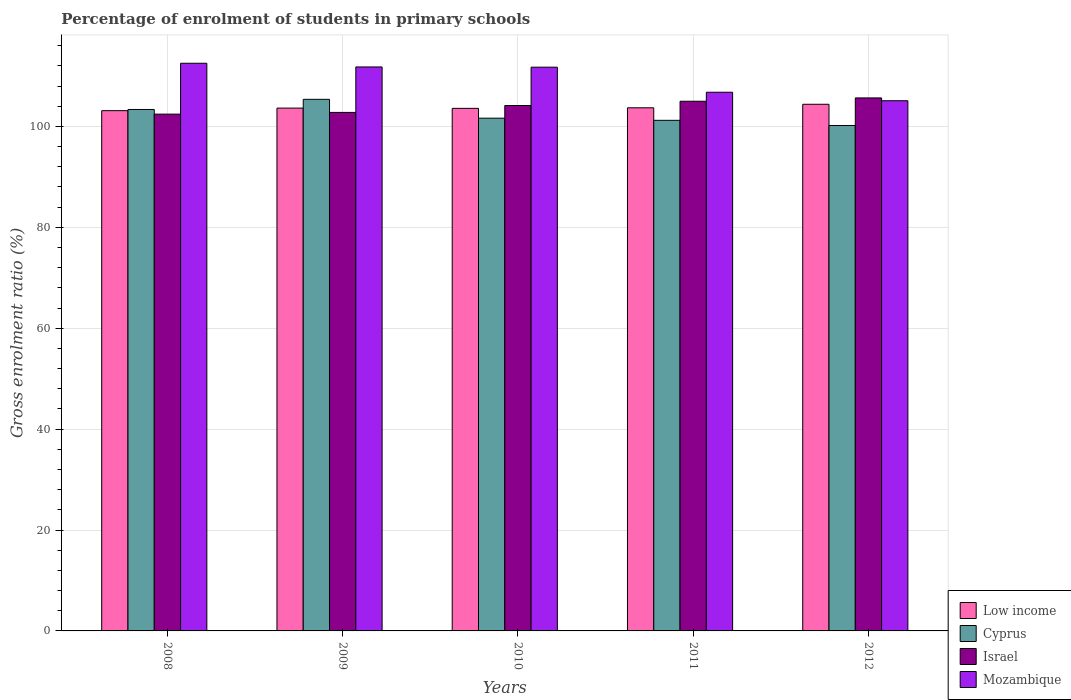How many groups of bars are there?
Your answer should be compact. 5. How many bars are there on the 2nd tick from the left?
Your answer should be very brief. 4. In how many cases, is the number of bars for a given year not equal to the number of legend labels?
Your response must be concise. 0. What is the percentage of students enrolled in primary schools in Israel in 2011?
Offer a terse response. 104.98. Across all years, what is the maximum percentage of students enrolled in primary schools in Cyprus?
Keep it short and to the point. 105.36. Across all years, what is the minimum percentage of students enrolled in primary schools in Mozambique?
Give a very brief answer. 105.08. In which year was the percentage of students enrolled in primary schools in Cyprus maximum?
Your response must be concise. 2009. In which year was the percentage of students enrolled in primary schools in Low income minimum?
Ensure brevity in your answer.  2008. What is the total percentage of students enrolled in primary schools in Israel in the graph?
Give a very brief answer. 519.96. What is the difference between the percentage of students enrolled in primary schools in Israel in 2010 and that in 2011?
Your answer should be compact. -0.85. What is the difference between the percentage of students enrolled in primary schools in Cyprus in 2008 and the percentage of students enrolled in primary schools in Low income in 2010?
Provide a short and direct response. -0.22. What is the average percentage of students enrolled in primary schools in Israel per year?
Your response must be concise. 103.99. In the year 2011, what is the difference between the percentage of students enrolled in primary schools in Low income and percentage of students enrolled in primary schools in Israel?
Make the answer very short. -1.3. In how many years, is the percentage of students enrolled in primary schools in Israel greater than 48 %?
Keep it short and to the point. 5. What is the ratio of the percentage of students enrolled in primary schools in Low income in 2009 to that in 2012?
Make the answer very short. 0.99. Is the difference between the percentage of students enrolled in primary schools in Low income in 2009 and 2010 greater than the difference between the percentage of students enrolled in primary schools in Israel in 2009 and 2010?
Your response must be concise. Yes. What is the difference between the highest and the second highest percentage of students enrolled in primary schools in Mozambique?
Your answer should be very brief. 0.73. What is the difference between the highest and the lowest percentage of students enrolled in primary schools in Cyprus?
Provide a succinct answer. 5.19. What does the 2nd bar from the left in 2012 represents?
Your response must be concise. Cyprus. What does the 1st bar from the right in 2009 represents?
Make the answer very short. Mozambique. Are all the bars in the graph horizontal?
Provide a short and direct response. No. Does the graph contain any zero values?
Offer a terse response. No. How are the legend labels stacked?
Make the answer very short. Vertical. What is the title of the graph?
Make the answer very short. Percentage of enrolment of students in primary schools. Does "United Arab Emirates" appear as one of the legend labels in the graph?
Ensure brevity in your answer.  No. What is the label or title of the Y-axis?
Your response must be concise. Gross enrolment ratio (%). What is the Gross enrolment ratio (%) in Low income in 2008?
Keep it short and to the point. 103.11. What is the Gross enrolment ratio (%) of Cyprus in 2008?
Give a very brief answer. 103.35. What is the Gross enrolment ratio (%) in Israel in 2008?
Your answer should be compact. 102.43. What is the Gross enrolment ratio (%) of Mozambique in 2008?
Give a very brief answer. 112.51. What is the Gross enrolment ratio (%) in Low income in 2009?
Your response must be concise. 103.62. What is the Gross enrolment ratio (%) in Cyprus in 2009?
Ensure brevity in your answer.  105.36. What is the Gross enrolment ratio (%) of Israel in 2009?
Your response must be concise. 102.77. What is the Gross enrolment ratio (%) of Mozambique in 2009?
Keep it short and to the point. 111.78. What is the Gross enrolment ratio (%) of Low income in 2010?
Give a very brief answer. 103.57. What is the Gross enrolment ratio (%) in Cyprus in 2010?
Your answer should be compact. 101.62. What is the Gross enrolment ratio (%) in Israel in 2010?
Offer a very short reply. 104.14. What is the Gross enrolment ratio (%) of Mozambique in 2010?
Keep it short and to the point. 111.73. What is the Gross enrolment ratio (%) in Low income in 2011?
Offer a terse response. 103.68. What is the Gross enrolment ratio (%) in Cyprus in 2011?
Your answer should be very brief. 101.2. What is the Gross enrolment ratio (%) of Israel in 2011?
Keep it short and to the point. 104.98. What is the Gross enrolment ratio (%) in Mozambique in 2011?
Your response must be concise. 106.77. What is the Gross enrolment ratio (%) of Low income in 2012?
Your answer should be compact. 104.38. What is the Gross enrolment ratio (%) of Cyprus in 2012?
Keep it short and to the point. 100.18. What is the Gross enrolment ratio (%) of Israel in 2012?
Your answer should be very brief. 105.64. What is the Gross enrolment ratio (%) of Mozambique in 2012?
Provide a short and direct response. 105.08. Across all years, what is the maximum Gross enrolment ratio (%) in Low income?
Make the answer very short. 104.38. Across all years, what is the maximum Gross enrolment ratio (%) of Cyprus?
Ensure brevity in your answer.  105.36. Across all years, what is the maximum Gross enrolment ratio (%) of Israel?
Offer a terse response. 105.64. Across all years, what is the maximum Gross enrolment ratio (%) of Mozambique?
Provide a succinct answer. 112.51. Across all years, what is the minimum Gross enrolment ratio (%) of Low income?
Your response must be concise. 103.11. Across all years, what is the minimum Gross enrolment ratio (%) in Cyprus?
Give a very brief answer. 100.18. Across all years, what is the minimum Gross enrolment ratio (%) in Israel?
Offer a very short reply. 102.43. Across all years, what is the minimum Gross enrolment ratio (%) in Mozambique?
Provide a short and direct response. 105.08. What is the total Gross enrolment ratio (%) in Low income in the graph?
Provide a succinct answer. 518.38. What is the total Gross enrolment ratio (%) in Cyprus in the graph?
Offer a terse response. 511.72. What is the total Gross enrolment ratio (%) of Israel in the graph?
Your answer should be compact. 519.96. What is the total Gross enrolment ratio (%) in Mozambique in the graph?
Keep it short and to the point. 547.87. What is the difference between the Gross enrolment ratio (%) of Low income in 2008 and that in 2009?
Provide a short and direct response. -0.51. What is the difference between the Gross enrolment ratio (%) of Cyprus in 2008 and that in 2009?
Offer a terse response. -2.01. What is the difference between the Gross enrolment ratio (%) in Israel in 2008 and that in 2009?
Your response must be concise. -0.34. What is the difference between the Gross enrolment ratio (%) in Mozambique in 2008 and that in 2009?
Provide a short and direct response. 0.73. What is the difference between the Gross enrolment ratio (%) of Low income in 2008 and that in 2010?
Your answer should be very brief. -0.46. What is the difference between the Gross enrolment ratio (%) in Cyprus in 2008 and that in 2010?
Keep it short and to the point. 1.73. What is the difference between the Gross enrolment ratio (%) of Israel in 2008 and that in 2010?
Ensure brevity in your answer.  -1.71. What is the difference between the Gross enrolment ratio (%) in Mozambique in 2008 and that in 2010?
Your answer should be very brief. 0.78. What is the difference between the Gross enrolment ratio (%) in Low income in 2008 and that in 2011?
Offer a terse response. -0.57. What is the difference between the Gross enrolment ratio (%) in Cyprus in 2008 and that in 2011?
Ensure brevity in your answer.  2.15. What is the difference between the Gross enrolment ratio (%) of Israel in 2008 and that in 2011?
Ensure brevity in your answer.  -2.56. What is the difference between the Gross enrolment ratio (%) in Mozambique in 2008 and that in 2011?
Offer a terse response. 5.74. What is the difference between the Gross enrolment ratio (%) in Low income in 2008 and that in 2012?
Keep it short and to the point. -1.27. What is the difference between the Gross enrolment ratio (%) in Cyprus in 2008 and that in 2012?
Your answer should be compact. 3.18. What is the difference between the Gross enrolment ratio (%) of Israel in 2008 and that in 2012?
Offer a very short reply. -3.21. What is the difference between the Gross enrolment ratio (%) of Mozambique in 2008 and that in 2012?
Offer a terse response. 7.43. What is the difference between the Gross enrolment ratio (%) of Low income in 2009 and that in 2010?
Your response must be concise. 0.05. What is the difference between the Gross enrolment ratio (%) in Cyprus in 2009 and that in 2010?
Your answer should be very brief. 3.74. What is the difference between the Gross enrolment ratio (%) of Israel in 2009 and that in 2010?
Your answer should be very brief. -1.37. What is the difference between the Gross enrolment ratio (%) in Mozambique in 2009 and that in 2010?
Provide a short and direct response. 0.05. What is the difference between the Gross enrolment ratio (%) of Low income in 2009 and that in 2011?
Make the answer very short. -0.06. What is the difference between the Gross enrolment ratio (%) of Cyprus in 2009 and that in 2011?
Offer a very short reply. 4.16. What is the difference between the Gross enrolment ratio (%) in Israel in 2009 and that in 2011?
Your response must be concise. -2.21. What is the difference between the Gross enrolment ratio (%) in Mozambique in 2009 and that in 2011?
Your answer should be compact. 5.01. What is the difference between the Gross enrolment ratio (%) in Low income in 2009 and that in 2012?
Your answer should be very brief. -0.76. What is the difference between the Gross enrolment ratio (%) of Cyprus in 2009 and that in 2012?
Keep it short and to the point. 5.19. What is the difference between the Gross enrolment ratio (%) of Israel in 2009 and that in 2012?
Ensure brevity in your answer.  -2.87. What is the difference between the Gross enrolment ratio (%) in Mozambique in 2009 and that in 2012?
Provide a succinct answer. 6.7. What is the difference between the Gross enrolment ratio (%) in Low income in 2010 and that in 2011?
Your response must be concise. -0.11. What is the difference between the Gross enrolment ratio (%) of Cyprus in 2010 and that in 2011?
Make the answer very short. 0.42. What is the difference between the Gross enrolment ratio (%) in Israel in 2010 and that in 2011?
Ensure brevity in your answer.  -0.85. What is the difference between the Gross enrolment ratio (%) of Mozambique in 2010 and that in 2011?
Your answer should be very brief. 4.96. What is the difference between the Gross enrolment ratio (%) of Low income in 2010 and that in 2012?
Provide a succinct answer. -0.81. What is the difference between the Gross enrolment ratio (%) in Cyprus in 2010 and that in 2012?
Your answer should be compact. 1.45. What is the difference between the Gross enrolment ratio (%) in Israel in 2010 and that in 2012?
Give a very brief answer. -1.5. What is the difference between the Gross enrolment ratio (%) in Mozambique in 2010 and that in 2012?
Provide a succinct answer. 6.65. What is the difference between the Gross enrolment ratio (%) in Low income in 2011 and that in 2012?
Keep it short and to the point. -0.7. What is the difference between the Gross enrolment ratio (%) in Cyprus in 2011 and that in 2012?
Make the answer very short. 1.03. What is the difference between the Gross enrolment ratio (%) of Israel in 2011 and that in 2012?
Ensure brevity in your answer.  -0.66. What is the difference between the Gross enrolment ratio (%) of Mozambique in 2011 and that in 2012?
Provide a short and direct response. 1.68. What is the difference between the Gross enrolment ratio (%) of Low income in 2008 and the Gross enrolment ratio (%) of Cyprus in 2009?
Your response must be concise. -2.25. What is the difference between the Gross enrolment ratio (%) of Low income in 2008 and the Gross enrolment ratio (%) of Israel in 2009?
Ensure brevity in your answer.  0.34. What is the difference between the Gross enrolment ratio (%) of Low income in 2008 and the Gross enrolment ratio (%) of Mozambique in 2009?
Offer a terse response. -8.66. What is the difference between the Gross enrolment ratio (%) of Cyprus in 2008 and the Gross enrolment ratio (%) of Israel in 2009?
Make the answer very short. 0.58. What is the difference between the Gross enrolment ratio (%) in Cyprus in 2008 and the Gross enrolment ratio (%) in Mozambique in 2009?
Make the answer very short. -8.43. What is the difference between the Gross enrolment ratio (%) of Israel in 2008 and the Gross enrolment ratio (%) of Mozambique in 2009?
Offer a very short reply. -9.35. What is the difference between the Gross enrolment ratio (%) in Low income in 2008 and the Gross enrolment ratio (%) in Cyprus in 2010?
Offer a terse response. 1.49. What is the difference between the Gross enrolment ratio (%) of Low income in 2008 and the Gross enrolment ratio (%) of Israel in 2010?
Provide a short and direct response. -1.02. What is the difference between the Gross enrolment ratio (%) in Low income in 2008 and the Gross enrolment ratio (%) in Mozambique in 2010?
Your answer should be very brief. -8.62. What is the difference between the Gross enrolment ratio (%) of Cyprus in 2008 and the Gross enrolment ratio (%) of Israel in 2010?
Offer a very short reply. -0.79. What is the difference between the Gross enrolment ratio (%) of Cyprus in 2008 and the Gross enrolment ratio (%) of Mozambique in 2010?
Provide a short and direct response. -8.38. What is the difference between the Gross enrolment ratio (%) in Israel in 2008 and the Gross enrolment ratio (%) in Mozambique in 2010?
Offer a very short reply. -9.3. What is the difference between the Gross enrolment ratio (%) in Low income in 2008 and the Gross enrolment ratio (%) in Cyprus in 2011?
Your answer should be compact. 1.91. What is the difference between the Gross enrolment ratio (%) of Low income in 2008 and the Gross enrolment ratio (%) of Israel in 2011?
Keep it short and to the point. -1.87. What is the difference between the Gross enrolment ratio (%) in Low income in 2008 and the Gross enrolment ratio (%) in Mozambique in 2011?
Give a very brief answer. -3.65. What is the difference between the Gross enrolment ratio (%) of Cyprus in 2008 and the Gross enrolment ratio (%) of Israel in 2011?
Offer a very short reply. -1.63. What is the difference between the Gross enrolment ratio (%) in Cyprus in 2008 and the Gross enrolment ratio (%) in Mozambique in 2011?
Your answer should be compact. -3.42. What is the difference between the Gross enrolment ratio (%) of Israel in 2008 and the Gross enrolment ratio (%) of Mozambique in 2011?
Offer a very short reply. -4.34. What is the difference between the Gross enrolment ratio (%) of Low income in 2008 and the Gross enrolment ratio (%) of Cyprus in 2012?
Give a very brief answer. 2.94. What is the difference between the Gross enrolment ratio (%) in Low income in 2008 and the Gross enrolment ratio (%) in Israel in 2012?
Your response must be concise. -2.53. What is the difference between the Gross enrolment ratio (%) of Low income in 2008 and the Gross enrolment ratio (%) of Mozambique in 2012?
Provide a short and direct response. -1.97. What is the difference between the Gross enrolment ratio (%) of Cyprus in 2008 and the Gross enrolment ratio (%) of Israel in 2012?
Offer a very short reply. -2.29. What is the difference between the Gross enrolment ratio (%) in Cyprus in 2008 and the Gross enrolment ratio (%) in Mozambique in 2012?
Keep it short and to the point. -1.73. What is the difference between the Gross enrolment ratio (%) of Israel in 2008 and the Gross enrolment ratio (%) of Mozambique in 2012?
Your answer should be very brief. -2.65. What is the difference between the Gross enrolment ratio (%) in Low income in 2009 and the Gross enrolment ratio (%) in Cyprus in 2010?
Provide a short and direct response. 2. What is the difference between the Gross enrolment ratio (%) of Low income in 2009 and the Gross enrolment ratio (%) of Israel in 2010?
Your answer should be very brief. -0.51. What is the difference between the Gross enrolment ratio (%) of Low income in 2009 and the Gross enrolment ratio (%) of Mozambique in 2010?
Offer a terse response. -8.11. What is the difference between the Gross enrolment ratio (%) in Cyprus in 2009 and the Gross enrolment ratio (%) in Israel in 2010?
Ensure brevity in your answer.  1.23. What is the difference between the Gross enrolment ratio (%) in Cyprus in 2009 and the Gross enrolment ratio (%) in Mozambique in 2010?
Give a very brief answer. -6.37. What is the difference between the Gross enrolment ratio (%) of Israel in 2009 and the Gross enrolment ratio (%) of Mozambique in 2010?
Give a very brief answer. -8.96. What is the difference between the Gross enrolment ratio (%) of Low income in 2009 and the Gross enrolment ratio (%) of Cyprus in 2011?
Ensure brevity in your answer.  2.42. What is the difference between the Gross enrolment ratio (%) of Low income in 2009 and the Gross enrolment ratio (%) of Israel in 2011?
Offer a very short reply. -1.36. What is the difference between the Gross enrolment ratio (%) of Low income in 2009 and the Gross enrolment ratio (%) of Mozambique in 2011?
Offer a terse response. -3.14. What is the difference between the Gross enrolment ratio (%) in Cyprus in 2009 and the Gross enrolment ratio (%) in Israel in 2011?
Provide a short and direct response. 0.38. What is the difference between the Gross enrolment ratio (%) in Cyprus in 2009 and the Gross enrolment ratio (%) in Mozambique in 2011?
Give a very brief answer. -1.4. What is the difference between the Gross enrolment ratio (%) of Israel in 2009 and the Gross enrolment ratio (%) of Mozambique in 2011?
Provide a short and direct response. -4. What is the difference between the Gross enrolment ratio (%) of Low income in 2009 and the Gross enrolment ratio (%) of Cyprus in 2012?
Provide a short and direct response. 3.45. What is the difference between the Gross enrolment ratio (%) in Low income in 2009 and the Gross enrolment ratio (%) in Israel in 2012?
Provide a succinct answer. -2.02. What is the difference between the Gross enrolment ratio (%) in Low income in 2009 and the Gross enrolment ratio (%) in Mozambique in 2012?
Your answer should be very brief. -1.46. What is the difference between the Gross enrolment ratio (%) of Cyprus in 2009 and the Gross enrolment ratio (%) of Israel in 2012?
Your answer should be compact. -0.28. What is the difference between the Gross enrolment ratio (%) in Cyprus in 2009 and the Gross enrolment ratio (%) in Mozambique in 2012?
Make the answer very short. 0.28. What is the difference between the Gross enrolment ratio (%) in Israel in 2009 and the Gross enrolment ratio (%) in Mozambique in 2012?
Your answer should be compact. -2.31. What is the difference between the Gross enrolment ratio (%) in Low income in 2010 and the Gross enrolment ratio (%) in Cyprus in 2011?
Your answer should be very brief. 2.37. What is the difference between the Gross enrolment ratio (%) of Low income in 2010 and the Gross enrolment ratio (%) of Israel in 2011?
Offer a terse response. -1.41. What is the difference between the Gross enrolment ratio (%) of Low income in 2010 and the Gross enrolment ratio (%) of Mozambique in 2011?
Your response must be concise. -3.19. What is the difference between the Gross enrolment ratio (%) in Cyprus in 2010 and the Gross enrolment ratio (%) in Israel in 2011?
Your answer should be compact. -3.36. What is the difference between the Gross enrolment ratio (%) of Cyprus in 2010 and the Gross enrolment ratio (%) of Mozambique in 2011?
Give a very brief answer. -5.14. What is the difference between the Gross enrolment ratio (%) of Israel in 2010 and the Gross enrolment ratio (%) of Mozambique in 2011?
Make the answer very short. -2.63. What is the difference between the Gross enrolment ratio (%) of Low income in 2010 and the Gross enrolment ratio (%) of Cyprus in 2012?
Give a very brief answer. 3.4. What is the difference between the Gross enrolment ratio (%) of Low income in 2010 and the Gross enrolment ratio (%) of Israel in 2012?
Give a very brief answer. -2.07. What is the difference between the Gross enrolment ratio (%) in Low income in 2010 and the Gross enrolment ratio (%) in Mozambique in 2012?
Provide a succinct answer. -1.51. What is the difference between the Gross enrolment ratio (%) of Cyprus in 2010 and the Gross enrolment ratio (%) of Israel in 2012?
Make the answer very short. -4.02. What is the difference between the Gross enrolment ratio (%) of Cyprus in 2010 and the Gross enrolment ratio (%) of Mozambique in 2012?
Provide a short and direct response. -3.46. What is the difference between the Gross enrolment ratio (%) in Israel in 2010 and the Gross enrolment ratio (%) in Mozambique in 2012?
Your answer should be compact. -0.94. What is the difference between the Gross enrolment ratio (%) in Low income in 2011 and the Gross enrolment ratio (%) in Cyprus in 2012?
Provide a succinct answer. 3.51. What is the difference between the Gross enrolment ratio (%) of Low income in 2011 and the Gross enrolment ratio (%) of Israel in 2012?
Keep it short and to the point. -1.96. What is the difference between the Gross enrolment ratio (%) of Low income in 2011 and the Gross enrolment ratio (%) of Mozambique in 2012?
Your answer should be very brief. -1.4. What is the difference between the Gross enrolment ratio (%) in Cyprus in 2011 and the Gross enrolment ratio (%) in Israel in 2012?
Your response must be concise. -4.44. What is the difference between the Gross enrolment ratio (%) in Cyprus in 2011 and the Gross enrolment ratio (%) in Mozambique in 2012?
Your response must be concise. -3.88. What is the difference between the Gross enrolment ratio (%) of Israel in 2011 and the Gross enrolment ratio (%) of Mozambique in 2012?
Offer a very short reply. -0.1. What is the average Gross enrolment ratio (%) of Low income per year?
Keep it short and to the point. 103.68. What is the average Gross enrolment ratio (%) in Cyprus per year?
Provide a succinct answer. 102.34. What is the average Gross enrolment ratio (%) of Israel per year?
Make the answer very short. 103.99. What is the average Gross enrolment ratio (%) of Mozambique per year?
Keep it short and to the point. 109.57. In the year 2008, what is the difference between the Gross enrolment ratio (%) in Low income and Gross enrolment ratio (%) in Cyprus?
Ensure brevity in your answer.  -0.24. In the year 2008, what is the difference between the Gross enrolment ratio (%) in Low income and Gross enrolment ratio (%) in Israel?
Your answer should be very brief. 0.69. In the year 2008, what is the difference between the Gross enrolment ratio (%) of Low income and Gross enrolment ratio (%) of Mozambique?
Keep it short and to the point. -9.4. In the year 2008, what is the difference between the Gross enrolment ratio (%) of Cyprus and Gross enrolment ratio (%) of Israel?
Offer a terse response. 0.92. In the year 2008, what is the difference between the Gross enrolment ratio (%) of Cyprus and Gross enrolment ratio (%) of Mozambique?
Offer a terse response. -9.16. In the year 2008, what is the difference between the Gross enrolment ratio (%) of Israel and Gross enrolment ratio (%) of Mozambique?
Offer a terse response. -10.08. In the year 2009, what is the difference between the Gross enrolment ratio (%) of Low income and Gross enrolment ratio (%) of Cyprus?
Your answer should be very brief. -1.74. In the year 2009, what is the difference between the Gross enrolment ratio (%) of Low income and Gross enrolment ratio (%) of Israel?
Your answer should be compact. 0.85. In the year 2009, what is the difference between the Gross enrolment ratio (%) in Low income and Gross enrolment ratio (%) in Mozambique?
Offer a terse response. -8.15. In the year 2009, what is the difference between the Gross enrolment ratio (%) in Cyprus and Gross enrolment ratio (%) in Israel?
Offer a very short reply. 2.6. In the year 2009, what is the difference between the Gross enrolment ratio (%) of Cyprus and Gross enrolment ratio (%) of Mozambique?
Keep it short and to the point. -6.41. In the year 2009, what is the difference between the Gross enrolment ratio (%) in Israel and Gross enrolment ratio (%) in Mozambique?
Provide a short and direct response. -9.01. In the year 2010, what is the difference between the Gross enrolment ratio (%) of Low income and Gross enrolment ratio (%) of Cyprus?
Ensure brevity in your answer.  1.95. In the year 2010, what is the difference between the Gross enrolment ratio (%) in Low income and Gross enrolment ratio (%) in Israel?
Give a very brief answer. -0.56. In the year 2010, what is the difference between the Gross enrolment ratio (%) in Low income and Gross enrolment ratio (%) in Mozambique?
Provide a short and direct response. -8.16. In the year 2010, what is the difference between the Gross enrolment ratio (%) in Cyprus and Gross enrolment ratio (%) in Israel?
Give a very brief answer. -2.51. In the year 2010, what is the difference between the Gross enrolment ratio (%) in Cyprus and Gross enrolment ratio (%) in Mozambique?
Make the answer very short. -10.11. In the year 2010, what is the difference between the Gross enrolment ratio (%) of Israel and Gross enrolment ratio (%) of Mozambique?
Give a very brief answer. -7.59. In the year 2011, what is the difference between the Gross enrolment ratio (%) in Low income and Gross enrolment ratio (%) in Cyprus?
Ensure brevity in your answer.  2.48. In the year 2011, what is the difference between the Gross enrolment ratio (%) in Low income and Gross enrolment ratio (%) in Israel?
Make the answer very short. -1.3. In the year 2011, what is the difference between the Gross enrolment ratio (%) in Low income and Gross enrolment ratio (%) in Mozambique?
Keep it short and to the point. -3.09. In the year 2011, what is the difference between the Gross enrolment ratio (%) in Cyprus and Gross enrolment ratio (%) in Israel?
Ensure brevity in your answer.  -3.78. In the year 2011, what is the difference between the Gross enrolment ratio (%) of Cyprus and Gross enrolment ratio (%) of Mozambique?
Make the answer very short. -5.57. In the year 2011, what is the difference between the Gross enrolment ratio (%) in Israel and Gross enrolment ratio (%) in Mozambique?
Provide a short and direct response. -1.78. In the year 2012, what is the difference between the Gross enrolment ratio (%) of Low income and Gross enrolment ratio (%) of Cyprus?
Offer a very short reply. 4.21. In the year 2012, what is the difference between the Gross enrolment ratio (%) of Low income and Gross enrolment ratio (%) of Israel?
Give a very brief answer. -1.26. In the year 2012, what is the difference between the Gross enrolment ratio (%) in Low income and Gross enrolment ratio (%) in Mozambique?
Your answer should be very brief. -0.7. In the year 2012, what is the difference between the Gross enrolment ratio (%) of Cyprus and Gross enrolment ratio (%) of Israel?
Provide a succinct answer. -5.47. In the year 2012, what is the difference between the Gross enrolment ratio (%) of Cyprus and Gross enrolment ratio (%) of Mozambique?
Ensure brevity in your answer.  -4.91. In the year 2012, what is the difference between the Gross enrolment ratio (%) of Israel and Gross enrolment ratio (%) of Mozambique?
Give a very brief answer. 0.56. What is the ratio of the Gross enrolment ratio (%) in Cyprus in 2008 to that in 2009?
Ensure brevity in your answer.  0.98. What is the ratio of the Gross enrolment ratio (%) of Mozambique in 2008 to that in 2009?
Keep it short and to the point. 1.01. What is the ratio of the Gross enrolment ratio (%) in Low income in 2008 to that in 2010?
Your response must be concise. 1. What is the ratio of the Gross enrolment ratio (%) of Cyprus in 2008 to that in 2010?
Your response must be concise. 1.02. What is the ratio of the Gross enrolment ratio (%) in Israel in 2008 to that in 2010?
Your response must be concise. 0.98. What is the ratio of the Gross enrolment ratio (%) of Cyprus in 2008 to that in 2011?
Your response must be concise. 1.02. What is the ratio of the Gross enrolment ratio (%) in Israel in 2008 to that in 2011?
Your answer should be very brief. 0.98. What is the ratio of the Gross enrolment ratio (%) of Mozambique in 2008 to that in 2011?
Your answer should be compact. 1.05. What is the ratio of the Gross enrolment ratio (%) of Low income in 2008 to that in 2012?
Offer a very short reply. 0.99. What is the ratio of the Gross enrolment ratio (%) in Cyprus in 2008 to that in 2012?
Offer a very short reply. 1.03. What is the ratio of the Gross enrolment ratio (%) of Israel in 2008 to that in 2012?
Give a very brief answer. 0.97. What is the ratio of the Gross enrolment ratio (%) in Mozambique in 2008 to that in 2012?
Your response must be concise. 1.07. What is the ratio of the Gross enrolment ratio (%) in Cyprus in 2009 to that in 2010?
Make the answer very short. 1.04. What is the ratio of the Gross enrolment ratio (%) in Israel in 2009 to that in 2010?
Offer a terse response. 0.99. What is the ratio of the Gross enrolment ratio (%) of Mozambique in 2009 to that in 2010?
Give a very brief answer. 1. What is the ratio of the Gross enrolment ratio (%) in Low income in 2009 to that in 2011?
Offer a terse response. 1. What is the ratio of the Gross enrolment ratio (%) in Cyprus in 2009 to that in 2011?
Your answer should be compact. 1.04. What is the ratio of the Gross enrolment ratio (%) in Israel in 2009 to that in 2011?
Keep it short and to the point. 0.98. What is the ratio of the Gross enrolment ratio (%) in Mozambique in 2009 to that in 2011?
Give a very brief answer. 1.05. What is the ratio of the Gross enrolment ratio (%) of Low income in 2009 to that in 2012?
Your answer should be compact. 0.99. What is the ratio of the Gross enrolment ratio (%) of Cyprus in 2009 to that in 2012?
Ensure brevity in your answer.  1.05. What is the ratio of the Gross enrolment ratio (%) in Israel in 2009 to that in 2012?
Ensure brevity in your answer.  0.97. What is the ratio of the Gross enrolment ratio (%) in Mozambique in 2009 to that in 2012?
Provide a short and direct response. 1.06. What is the ratio of the Gross enrolment ratio (%) in Low income in 2010 to that in 2011?
Your response must be concise. 1. What is the ratio of the Gross enrolment ratio (%) in Cyprus in 2010 to that in 2011?
Give a very brief answer. 1. What is the ratio of the Gross enrolment ratio (%) of Israel in 2010 to that in 2011?
Your answer should be compact. 0.99. What is the ratio of the Gross enrolment ratio (%) in Mozambique in 2010 to that in 2011?
Give a very brief answer. 1.05. What is the ratio of the Gross enrolment ratio (%) in Cyprus in 2010 to that in 2012?
Your answer should be very brief. 1.01. What is the ratio of the Gross enrolment ratio (%) in Israel in 2010 to that in 2012?
Give a very brief answer. 0.99. What is the ratio of the Gross enrolment ratio (%) of Mozambique in 2010 to that in 2012?
Your response must be concise. 1.06. What is the ratio of the Gross enrolment ratio (%) of Cyprus in 2011 to that in 2012?
Your answer should be very brief. 1.01. What is the ratio of the Gross enrolment ratio (%) in Israel in 2011 to that in 2012?
Offer a very short reply. 0.99. What is the difference between the highest and the second highest Gross enrolment ratio (%) of Low income?
Your response must be concise. 0.7. What is the difference between the highest and the second highest Gross enrolment ratio (%) in Cyprus?
Your response must be concise. 2.01. What is the difference between the highest and the second highest Gross enrolment ratio (%) in Israel?
Make the answer very short. 0.66. What is the difference between the highest and the second highest Gross enrolment ratio (%) of Mozambique?
Provide a short and direct response. 0.73. What is the difference between the highest and the lowest Gross enrolment ratio (%) in Low income?
Your response must be concise. 1.27. What is the difference between the highest and the lowest Gross enrolment ratio (%) in Cyprus?
Your answer should be very brief. 5.19. What is the difference between the highest and the lowest Gross enrolment ratio (%) of Israel?
Keep it short and to the point. 3.21. What is the difference between the highest and the lowest Gross enrolment ratio (%) in Mozambique?
Ensure brevity in your answer.  7.43. 